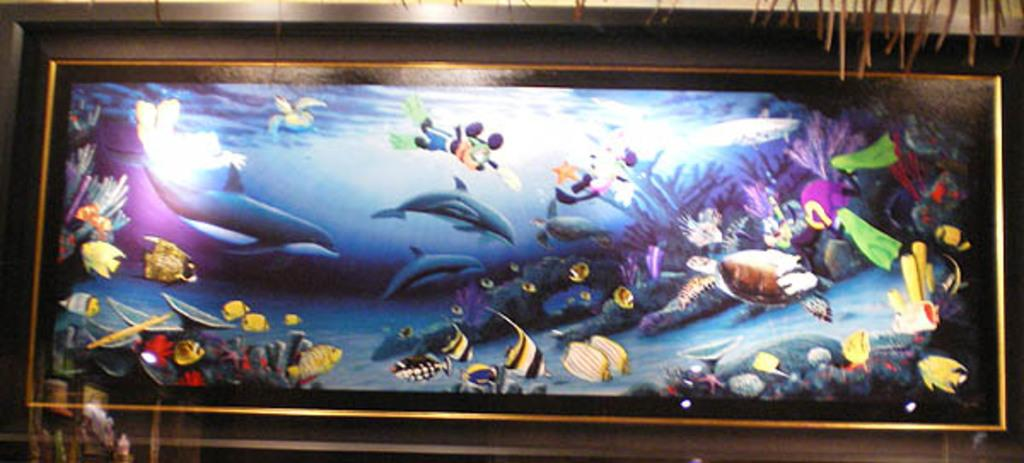What object is present in the image that typically holds a picture? There is a photo frame in the image. What is depicted in the photo frame? The photo frame contains a picture of fishes. What can be seen behind the photo frame in the image? There is a wall in the background of the image. How many babies are visible in the image? There are no babies present in the image. What type of battle is taking place in the image? There is no battle present in the image. 